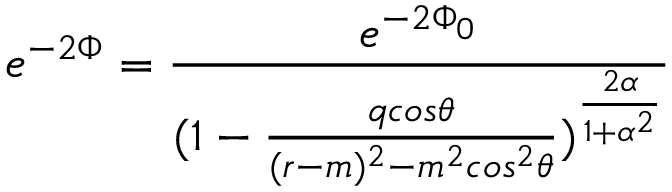Convert formula to latex. <formula><loc_0><loc_0><loc_500><loc_500>e ^ { - 2 \Phi } = { \frac { e ^ { - 2 \Phi _ { 0 } } } { ( 1 - { \frac { q \cos \theta } { ( r - m ) ^ { 2 } - m ^ { 2 } \cos ^ { 2 } \theta } } ) ^ { \frac { 2 \alpha } { 1 + \alpha ^ { 2 } } } } }</formula> 